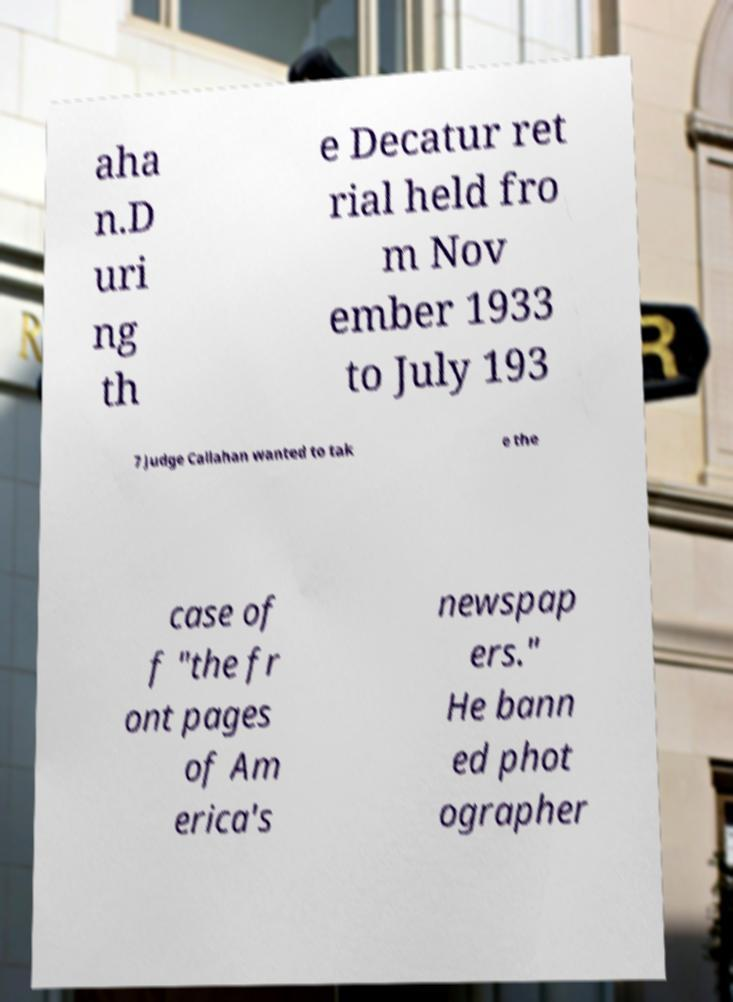For documentation purposes, I need the text within this image transcribed. Could you provide that? aha n.D uri ng th e Decatur ret rial held fro m Nov ember 1933 to July 193 7 Judge Callahan wanted to tak e the case of f "the fr ont pages of Am erica's newspap ers." He bann ed phot ographer 